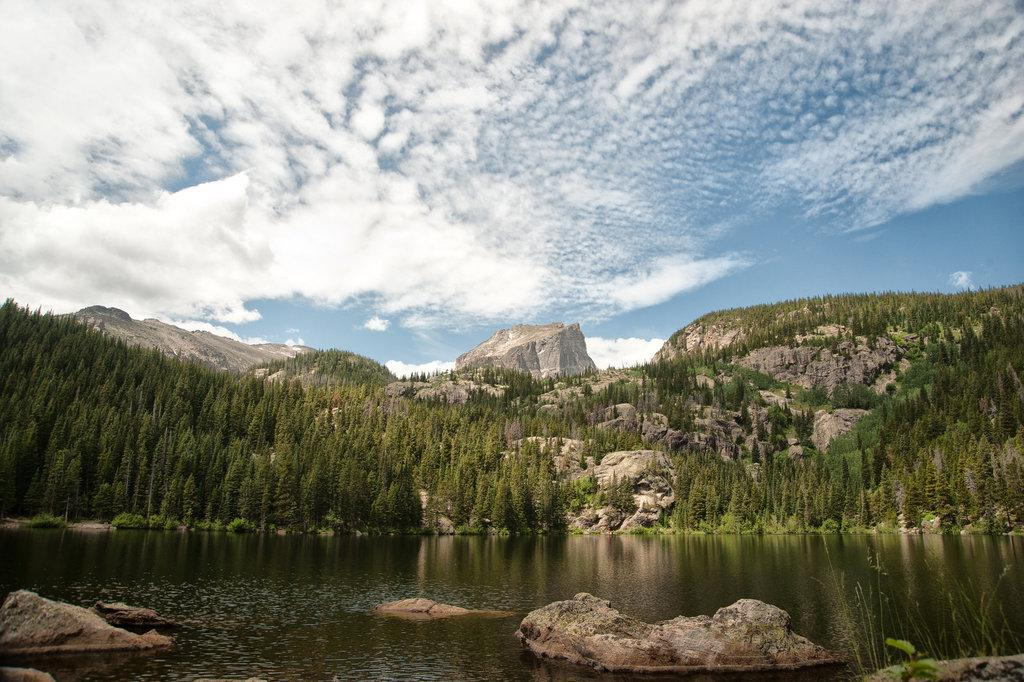What type of natural body of water is present in the image? There is a lake in the picture. What other natural elements can be seen in the image? There are plants and rocks in the lake. What is visible in the background of the picture? There are mountains in the background of the picture. What is the condition of the sky in the image? The sky is clear in the picture. Can you tell me how many pieces of cheese are floating in the lake in the image? There is no cheese present in the image; it features a lake with plants and rocks. Is there a kite flying in the sky in the image? There is no kite visible in the image; the sky is clear. 